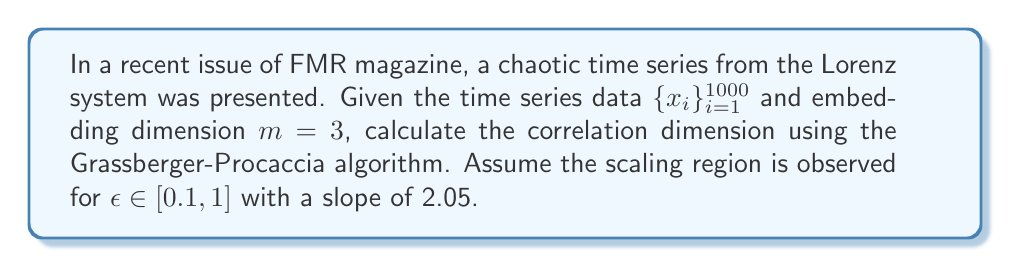What is the answer to this math problem? To calculate the correlation dimension of a chaotic time series using the Grassberger-Procaccia algorithm, follow these steps:

1. Construct delay vectors:
   $$\vec{x_i} = (x_i, x_{i+\tau}, x_{i+2\tau})$$
   where $\tau$ is the time delay (assumed to be 1 for simplicity).

2. Calculate the correlation sum:
   $$C(\epsilon) = \frac{2}{N(N-1)} \sum_{i=1}^{N} \sum_{j=i+1}^{N} \Theta(\epsilon - \|\vec{x_i} - \vec{x_j}\|)$$
   where $\Theta$ is the Heaviside step function and $N$ is the number of points.

3. Plot $\log(C(\epsilon))$ vs $\log(\epsilon)$ and identify the scaling region.

4. The correlation dimension $D_2$ is the slope of the scaling region:
   $$D_2 = \lim_{\epsilon \to 0} \frac{d\log(C(\epsilon))}{d\log(\epsilon)}$$

Given that the scaling region is observed for $\epsilon \in [0.1, 1]$ with a slope of 2.05, we can conclude that the correlation dimension $D_2 = 2.05$.
Answer: $D_2 = 2.05$ 